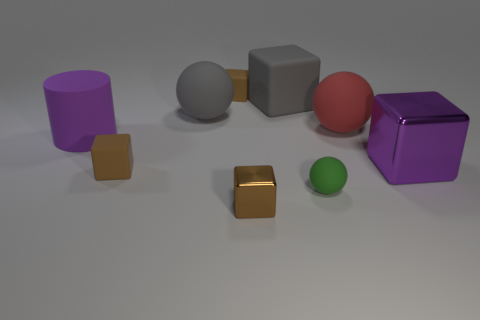Is the color of the cylinder the same as the metallic cube to the right of the big gray matte cube?
Your response must be concise. Yes. Is the large gray sphere made of the same material as the big purple thing left of the big metal block?
Offer a terse response. Yes. Are there the same number of tiny green matte spheres that are left of the small metal object and purple shiny cubes that are on the right side of the gray matte sphere?
Provide a short and direct response. No. What is the purple cube made of?
Give a very brief answer. Metal. What color is the other metallic thing that is the same size as the green object?
Provide a succinct answer. Brown. Is there a large purple metal block that is in front of the tiny brown rubber object that is behind the purple metal cube?
Give a very brief answer. Yes. How many cubes are matte things or brown matte objects?
Offer a terse response. 3. What is the size of the brown matte thing left of the small brown matte block behind the big ball that is on the left side of the small green rubber object?
Offer a terse response. Small. There is a large red matte sphere; are there any brown shiny blocks in front of it?
Your response must be concise. Yes. What is the shape of the big object that is the same color as the large rubber cylinder?
Provide a succinct answer. Cube. 